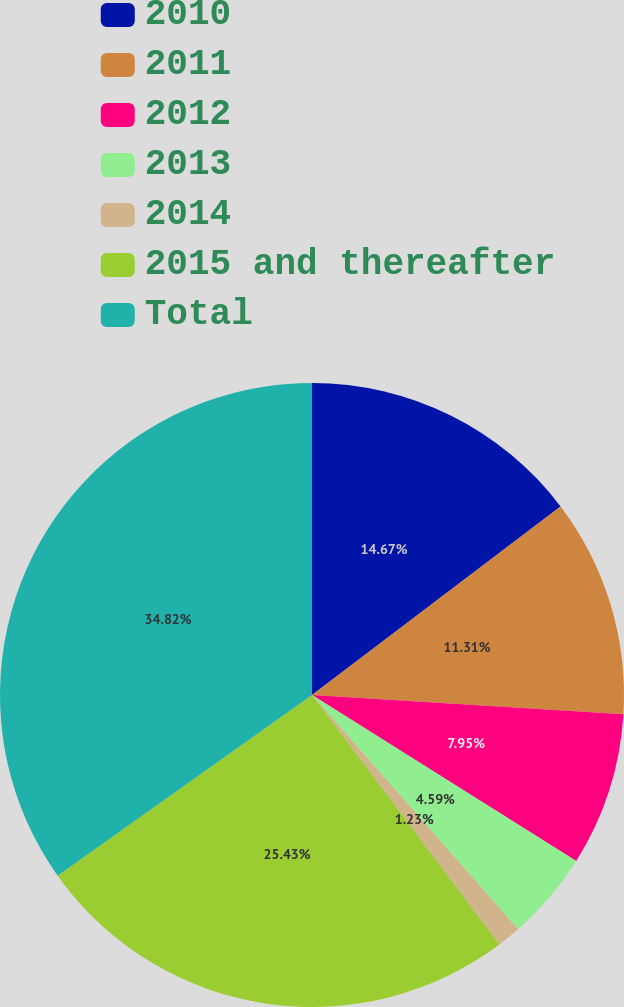Convert chart. <chart><loc_0><loc_0><loc_500><loc_500><pie_chart><fcel>2010<fcel>2011<fcel>2012<fcel>2013<fcel>2014<fcel>2015 and thereafter<fcel>Total<nl><fcel>14.67%<fcel>11.31%<fcel>7.95%<fcel>4.59%<fcel>1.23%<fcel>25.43%<fcel>34.83%<nl></chart> 